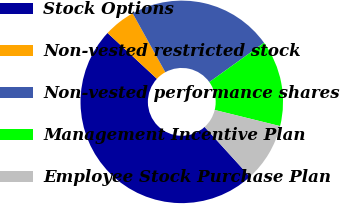Convert chart. <chart><loc_0><loc_0><loc_500><loc_500><pie_chart><fcel>Stock Options<fcel>Non-vested restricted stock<fcel>Non-vested performance shares<fcel>Management Incentive Plan<fcel>Employee Stock Purchase Plan<nl><fcel>48.66%<fcel>5.03%<fcel>23.15%<fcel>13.76%<fcel>9.4%<nl></chart> 